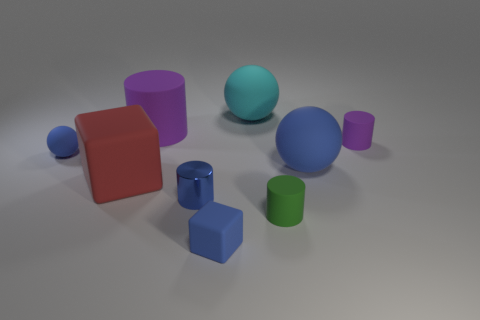Subtract all gray cylinders. Subtract all yellow blocks. How many cylinders are left? 4 Add 1 cyan rubber things. How many objects exist? 10 Subtract all cylinders. How many objects are left? 5 Subtract all yellow matte cylinders. Subtract all big cylinders. How many objects are left? 8 Add 2 small metal cylinders. How many small metal cylinders are left? 3 Add 3 tiny red balls. How many tiny red balls exist? 3 Subtract 0 gray cylinders. How many objects are left? 9 